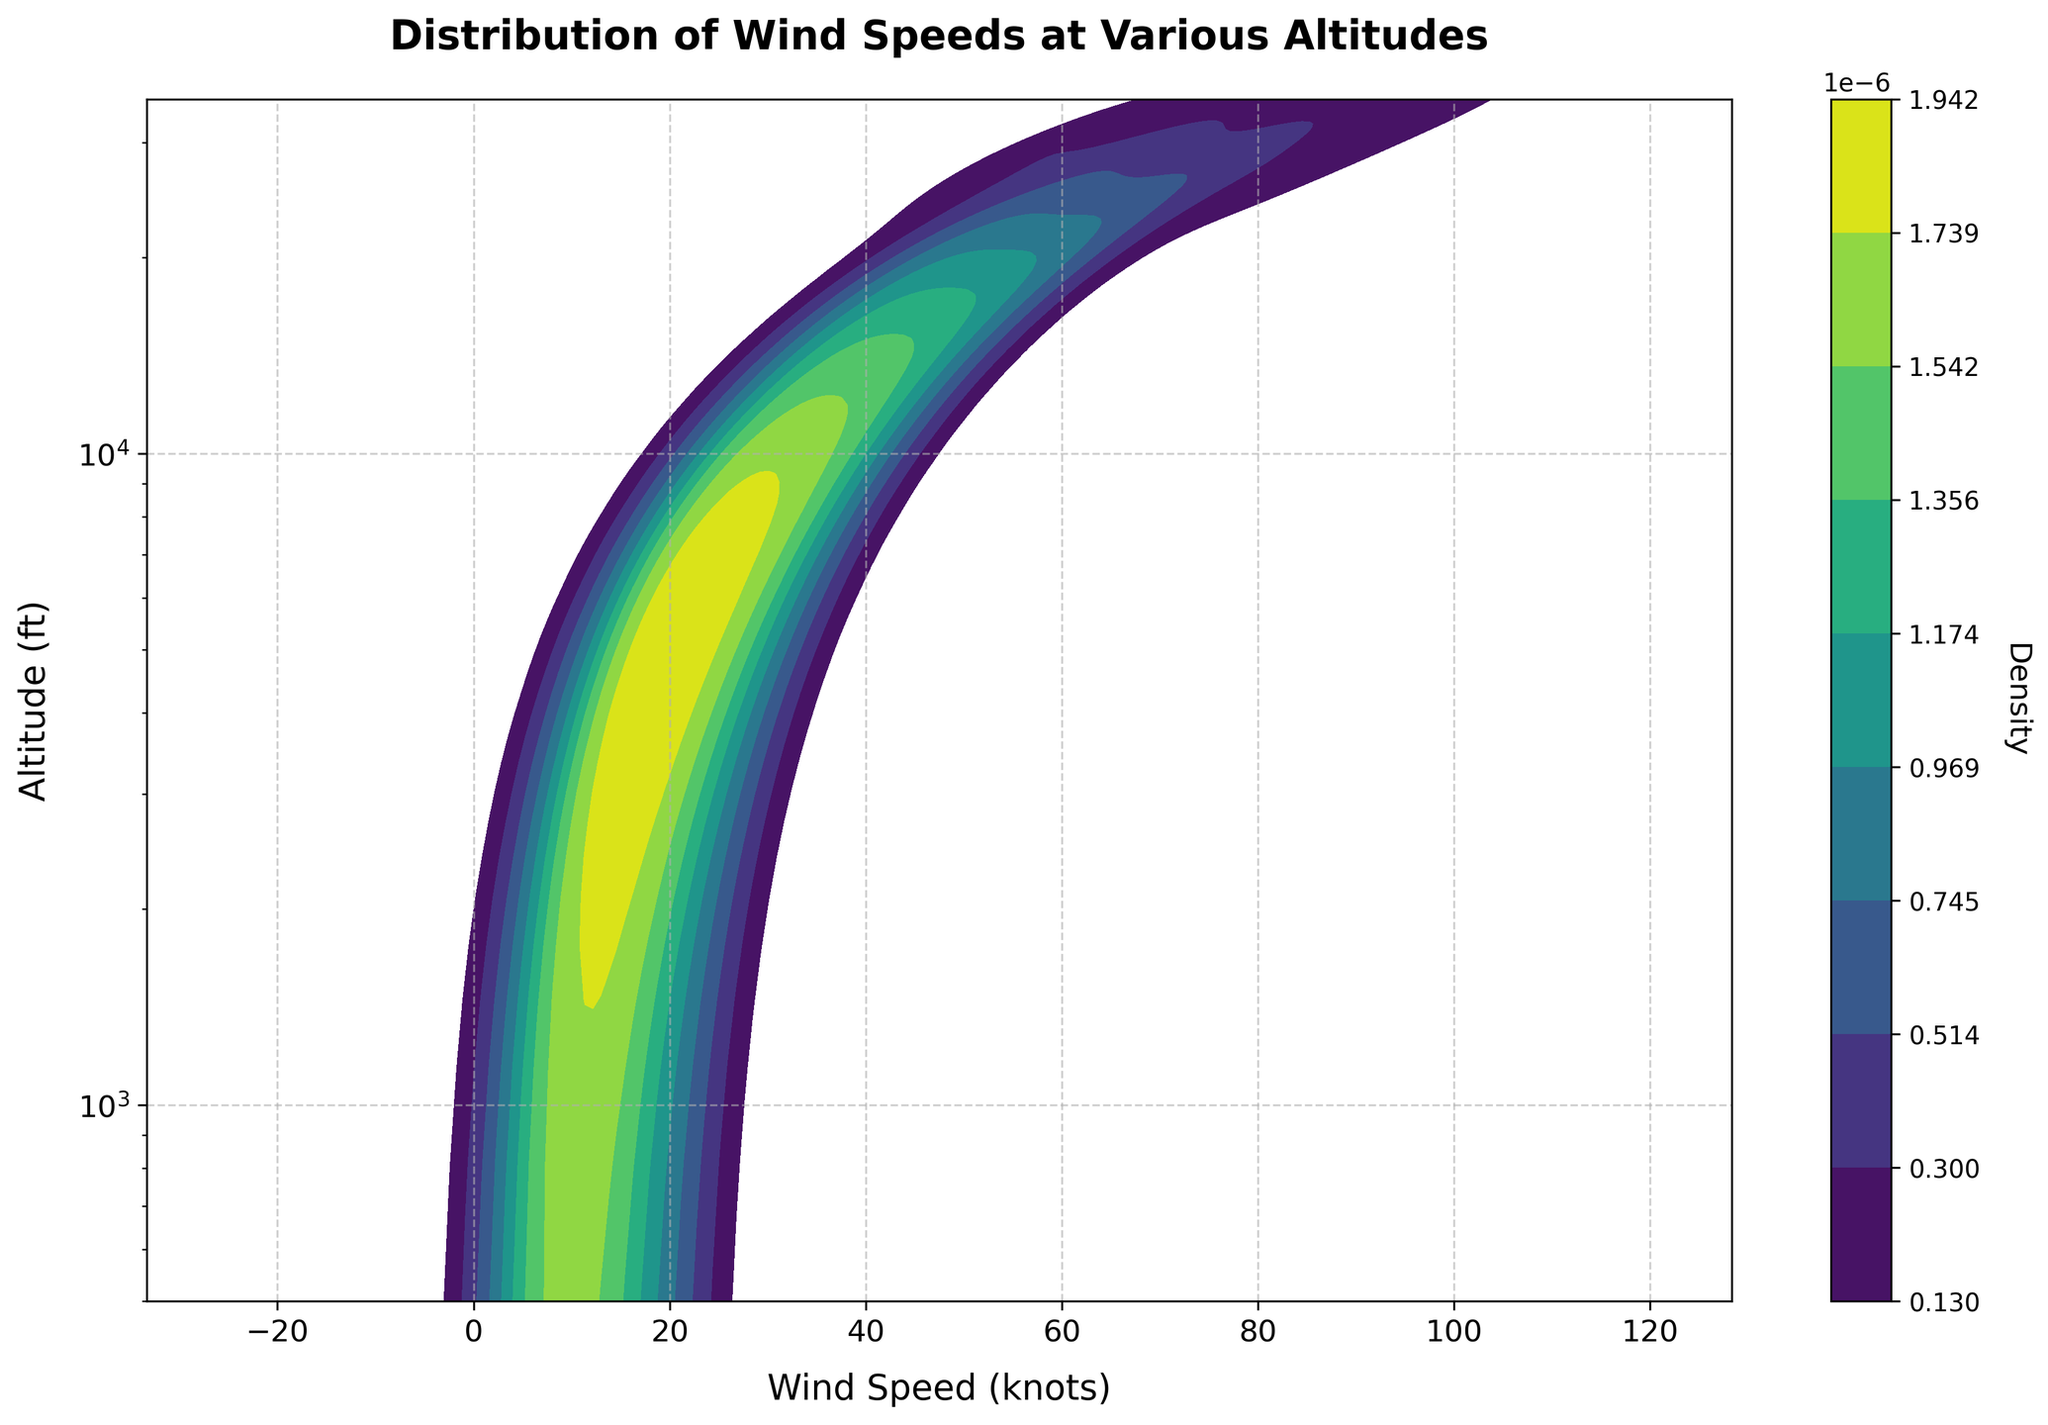What is the title of the plot? The title of the plot is displayed at the top of the figure. It usually describes the content of the figure. The title in this case is 'Distribution of Wind Speeds at Various Altitudes'.
Answer: Distribution of Wind Speeds at Various Altitudes What does the x-axis represent? The x-axis is labeled on the horizontal axis of the plot. It shows the variable being measured horizontally, which in this case is 'Wind Speed (knots)'.
Answer: Wind Speed (knots) What is the range of the y-axis? The y-axis represents the altitude in feet, and it is presented on a logarithmic scale. The range is indicated from the bottom to the top of the axis, going from 500 feet to 35,000 feet.
Answer: 500 to 35,000 feet What color is used to indicate higher density in the plot? The color that indicates higher density in the plot can be observed from the color gradient in the figure. In this case, dark areas represent higher density.
Answer: Dark How does wind speed density vary with altitude from 1,000 ft to 3,000 ft? By observing the density plot between 1,000 ft and 3,000 ft, you can see the changes in shades and density areas. At lower altitudes (1,000 ft), wind speeds are generally lower and more dispersed. As altitude increases to 3,000 ft, wind speeds increase and become denser.
Answer: Wind speeds increase and become denser At what altitude range is the wind speed the highest? Observe where the darkest shades appear along the y-axis, which indicates the highest density of wind speeds. The highest wind speeds are found at altitudes of 30,000 ft, as indicated by the dark areas.
Answer: 30,000 ft Are wind speeds more variable at lower or higher altitudes? To determine variability, look at the spread of the density areas. Higher variability shows a more spread out and irregular shape, whereas lower variability shows concentrated and more defined areas. The lower altitudes have more spread out and dispersed density areas compared to the higher altitudes, where the density is more concentrated.
Answer: Lower altitudes How does the density of wind speeds change above 20,000 ft compared to below 10,000 ft? Examine the density distributions in these altitude ranges. Above 20,000 ft, wind speeds are higher and show denser aggregation, while below 10,000 ft, wind speeds are lower and more dispersed.
Answer: Above 20,000 ft, denser and higher; below 10,000 ft, more dispersed and lower What is the approximate wind speed range at 15,000 ft? Observe the density distribution along the x-axis at the altitude of 15,000 ft. The wind speeds at this altitude range approximately from 35 to 50 knots.
Answer: 35 to 50 knots 